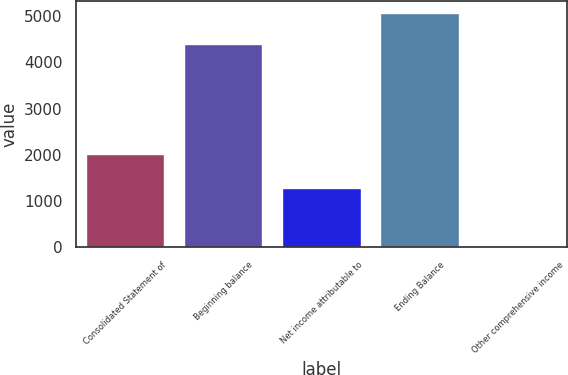Convert chart. <chart><loc_0><loc_0><loc_500><loc_500><bar_chart><fcel>Consolidated Statement of<fcel>Beginning balance<fcel>Net income attributable to<fcel>Ending Balance<fcel>Other comprehensive income<nl><fcel>2010<fcel>4390<fcel>1287<fcel>5071<fcel>22<nl></chart> 